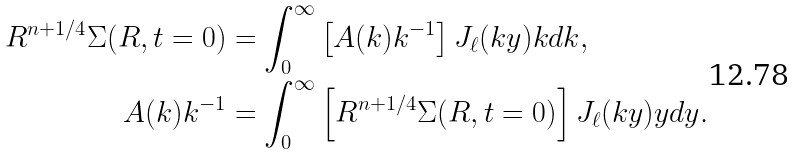Convert formula to latex. <formula><loc_0><loc_0><loc_500><loc_500>R ^ { n + 1 / 4 } \Sigma ( R , t = 0 ) & = \int _ { 0 } ^ { \infty } \left [ A ( k ) k ^ { - 1 } \right ] J _ { \ell } ( k y ) k d k , \\ A ( k ) k ^ { - 1 } & = \int _ { 0 } ^ { \infty } \left [ R ^ { n + 1 / 4 } \Sigma ( R , t = 0 ) \right ] J _ { \ell } ( k y ) y d y .</formula> 